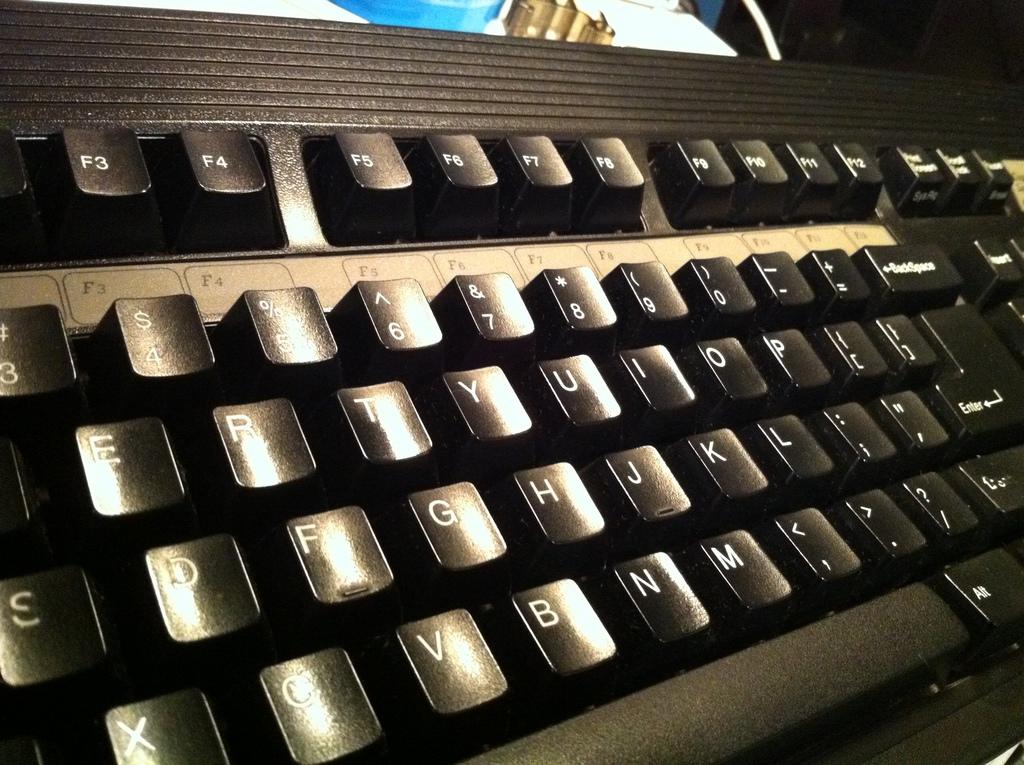Which key is the first key we can see in the top row on the left?
Your response must be concise. F3. What is the letter below y?
Keep it short and to the point. H. 